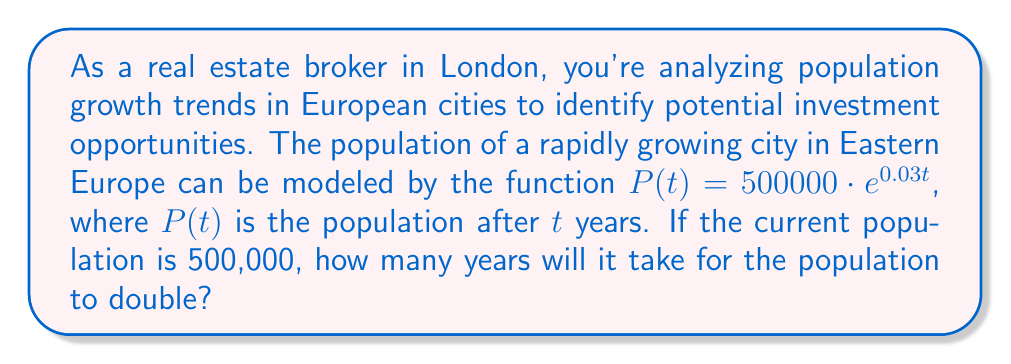Provide a solution to this math problem. To solve this problem, we need to use the properties of logarithms and exponential functions. Let's approach this step-by-step:

1) We're looking for the time $t$ when the population will be double the initial population. So, we need to solve:

   $500000 \cdot e^{0.03t} = 2 \cdot 500000$

2) Simplify the right side:

   $500000 \cdot e^{0.03t} = 1000000$

3) Divide both sides by 500000:

   $e^{0.03t} = 2$

4) Now, we can take the natural logarithm of both sides. Remember, $\ln(e^x) = x$:

   $\ln(e^{0.03t}) = \ln(2)$
   $0.03t = \ln(2)$

5) Solve for $t$ by dividing both sides by 0.03:

   $t = \frac{\ln(2)}{0.03}$

6) Calculate the result:

   $t \approx 23.10$ years

Therefore, it will take approximately 23.10 years for the population to double.
Answer: $23.10$ years 